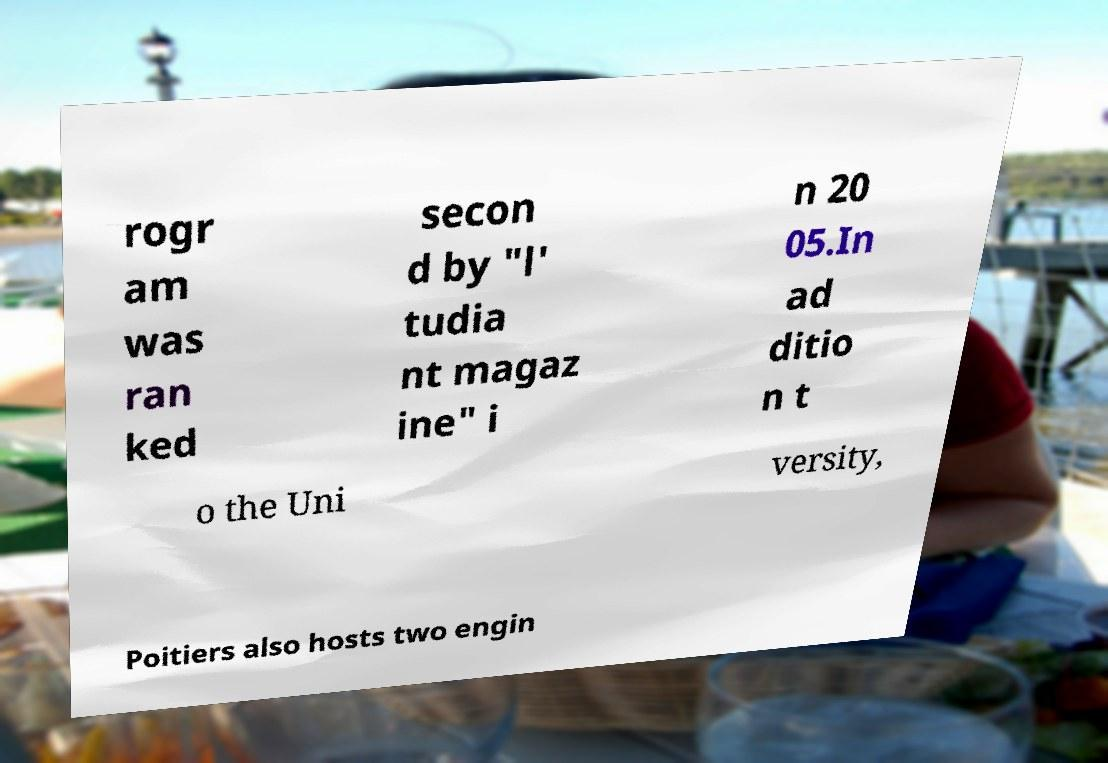I need the written content from this picture converted into text. Can you do that? rogr am was ran ked secon d by "l' tudia nt magaz ine" i n 20 05.In ad ditio n t o the Uni versity, Poitiers also hosts two engin 